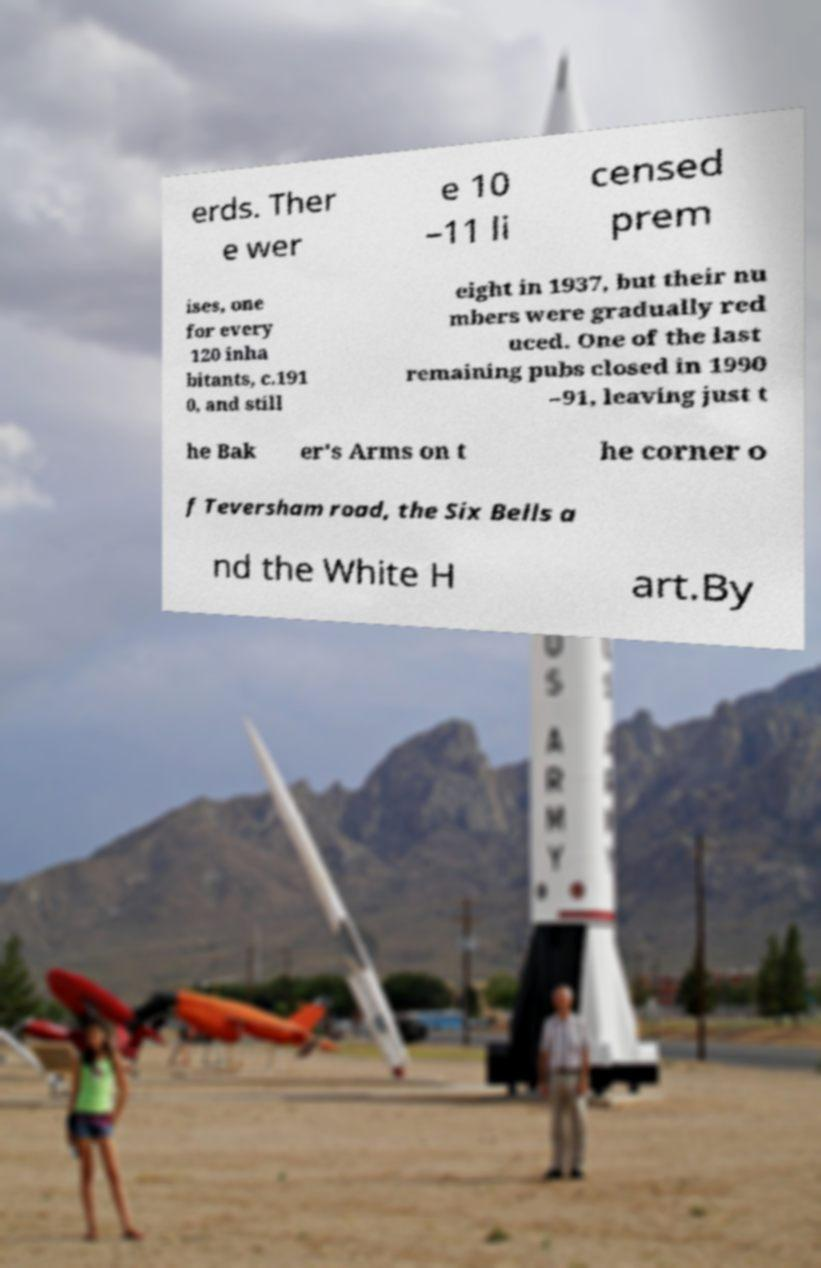Could you assist in decoding the text presented in this image and type it out clearly? erds. Ther e wer e 10 –11 li censed prem ises, one for every 120 inha bitants, c.191 0, and still eight in 1937, but their nu mbers were gradually red uced. One of the last remaining pubs closed in 1990 –91, leaving just t he Bak er's Arms on t he corner o f Teversham road, the Six Bells a nd the White H art.By 